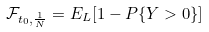<formula> <loc_0><loc_0><loc_500><loc_500>\mathcal { F } _ { t _ { 0 } , \frac { 1 } { N } } = E _ { L } [ 1 - P \{ Y > 0 \} ]</formula> 